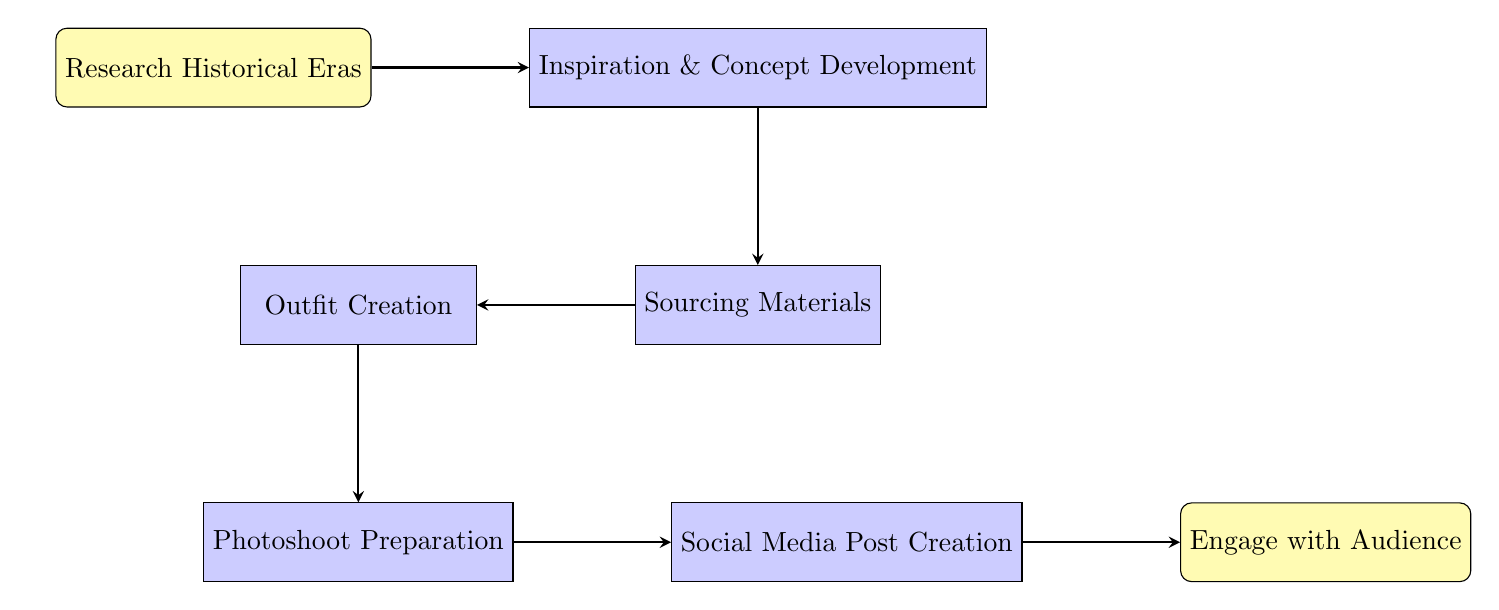What's the first step in the flowchart? The first step is labeled "Research Historical Eras," which indicates the starting point of the process.
Answer: Research Historical Eras How many total steps are there in the diagram? The diagram contains a total of six steps, excluding the starting and ending nodes. These are researched, inspiration, sourcing, creation, photoshoot, and social media post creation.
Answer: Six What follows "Sourcing Materials" in the process? After the "Sourcing Materials" step, the next step is "Outfit Creation." This indicates the order of operations in the flowchart.
Answer: Outfit Creation Which step directly precedes "Social Media Post Creation"? The step that directly precedes "Social Media Post Creation" is "Photoshoot Preparation," representing the sequential workflow leading to the posting.
Answer: Photoshoot Preparation Is "Engage with Audience" the last step in the diagram? Yes, "Engage with Audience" is indeed the last step, indicating that audience interaction happens after posting on social media.
Answer: Yes What is the focal point of the "Inspiration & Concept Development" step? The focal point is to "Pick a focal historical element," highlighting an important action in the concept development process.
Answer: Pick a focal historical element What is one of the sub-steps under "Photoshoot Preparation"? One of the sub-steps is "Choose a historically appropriate setting," which illustrates an action taken during the photoshoot setup.
Answer: Choose a historically appropriate setting Which step involves interaction with followers? The step that involves interaction with followers is "Engage with Audience," emphasizing the importance of audience engagement post-sharing.
Answer: Engage with Audience What type of materials are sought during the "Sourcing Materials" step? During this step, the focus is on "authentic materials," which shows that there is a specific quality of materials sought after.
Answer: Authentic materials 